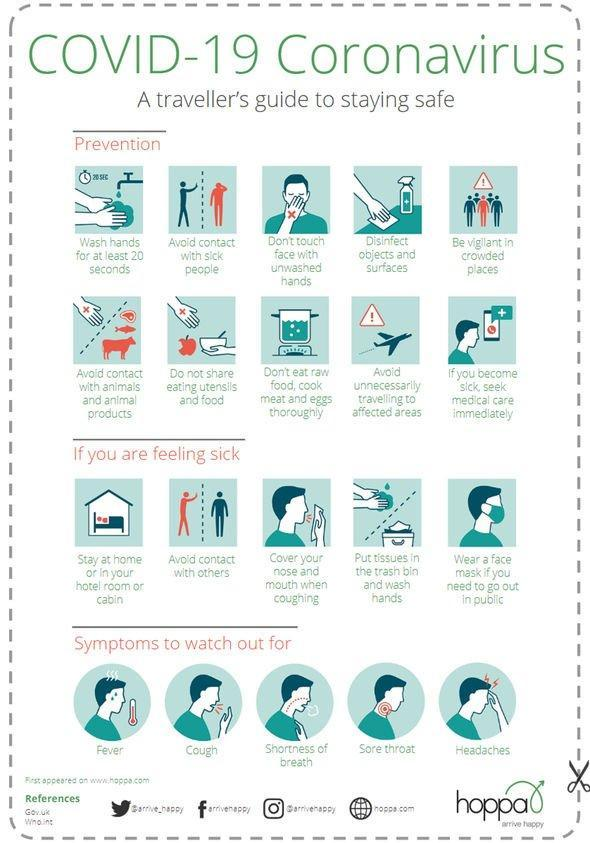What is the ninth tip mentioned for prevention of coronavirus infection?
Answer the question with a short phrase. Avoid unnecessarily travelling to affected areas What is the second tip mentioned for prevention of coronavirus infection? Avoid contact with sick people How many symptoms are shown in the image? 5 How many tips are mentioned for prevention of coronavirus? 10 What is mentioned third in the steps to be taken if one is feeling sick? Cover your nose and mouth when coughing What is the third symptom mentioned? Shortness of breath 